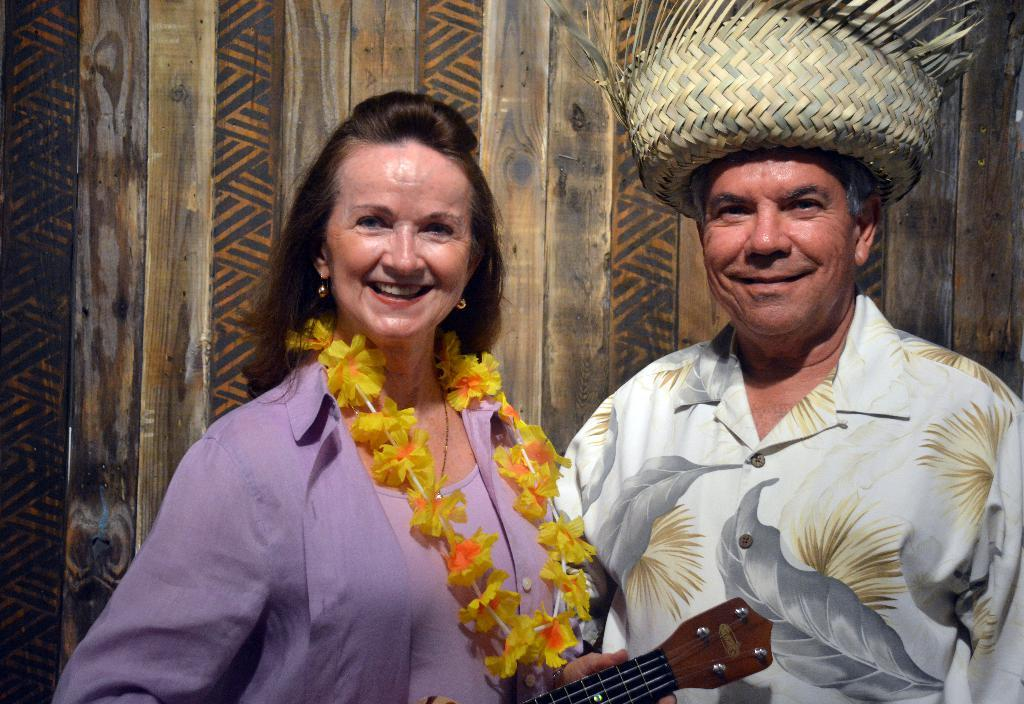Who are the people in the image? There is a couple in the image. What is the woman holding in the image? The woman is holding a guitar. What accessory is the man wearing in the image? The man is wearing a hat. What type of cheese is being served on the pancake in the image? There is no cheese or pancake present in the image; it features a couple, with the woman holding a guitar and the man wearing a hat. 